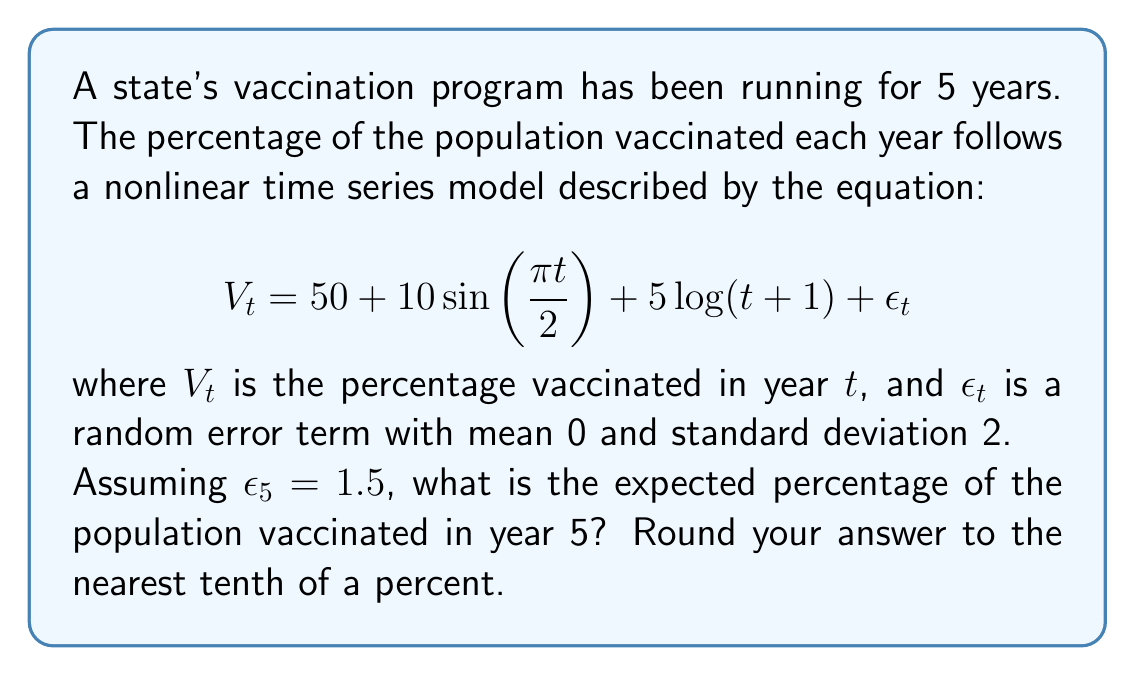Give your solution to this math problem. To solve this problem, we need to follow these steps:

1) Identify the components of the equation:
   - Base percentage: 50%
   - Cyclical component: $10\sin(\frac{\pi t}{2})$
   - Trend component: $5\log(t+1)$
   - Error term: $\epsilon_t$

2) Substitute $t = 5$ into the equation:

   $$V_5 = 50 + 10\sin(\frac{\pi \cdot 5}{2}) + 5\log(5+1) + \epsilon_5$$

3) Calculate each component:
   - Base: 50%
   - Cyclical: $10\sin(\frac{5\pi}{2}) = 10\sin(2.5\pi) = 10 \cdot 0 = 0$
   - Trend: $5\log(6) \approx 5 \cdot 1.7918 \approx 8.959$
   - Error: Given as 1.5

4) Sum all components:

   $$V_5 = 50 + 0 + 8.959 + 1.5 = 60.459$$

5) Round to the nearest tenth:

   60.459% ≈ 60.5%
Answer: 60.5% 